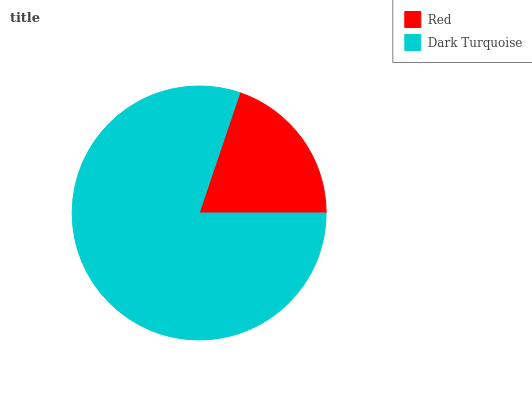Is Red the minimum?
Answer yes or no. Yes. Is Dark Turquoise the maximum?
Answer yes or no. Yes. Is Dark Turquoise the minimum?
Answer yes or no. No. Is Dark Turquoise greater than Red?
Answer yes or no. Yes. Is Red less than Dark Turquoise?
Answer yes or no. Yes. Is Red greater than Dark Turquoise?
Answer yes or no. No. Is Dark Turquoise less than Red?
Answer yes or no. No. Is Dark Turquoise the high median?
Answer yes or no. Yes. Is Red the low median?
Answer yes or no. Yes. Is Red the high median?
Answer yes or no. No. Is Dark Turquoise the low median?
Answer yes or no. No. 